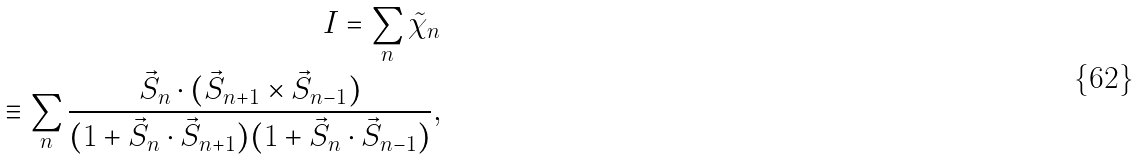<formula> <loc_0><loc_0><loc_500><loc_500>I = \sum _ { n } { \tilde { \chi } } _ { n } \\ \equiv \sum _ { n } \frac { \vec { S } _ { n } \cdot ( \vec { S } _ { n + 1 } \times \vec { S } _ { n - 1 } ) } { ( 1 + \vec { S } _ { n } \cdot \vec { S } _ { n + 1 } ) ( 1 + \vec { S } _ { n } \cdot \vec { S } _ { n - 1 } ) } ,</formula> 